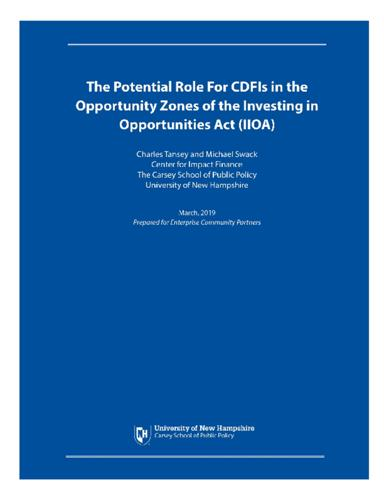Who are the authors of the document? The document was authored by Charles Tansey and Michael Swack, both of whom are notable figures associated with the Center for Impact Finance at The Carsey School of Public Policy, University of New Hampshire. 